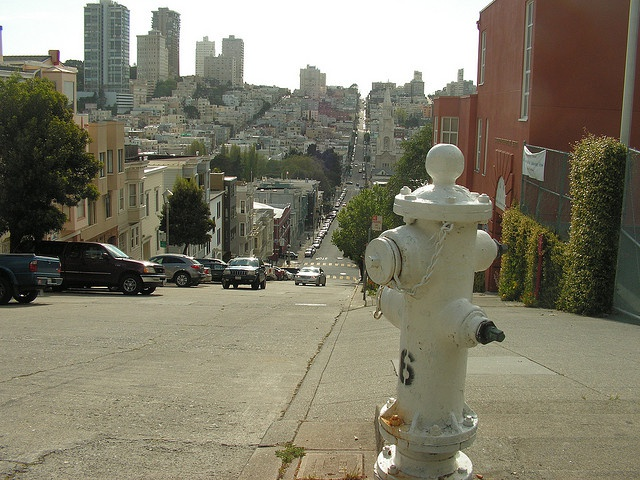Describe the objects in this image and their specific colors. I can see fire hydrant in white, gray, and darkgray tones, car in white, black, gray, and ivory tones, truck in white, black, gray, ivory, and darkgray tones, truck in white, black, gray, purple, and maroon tones, and car in white, black, gray, and purple tones in this image. 